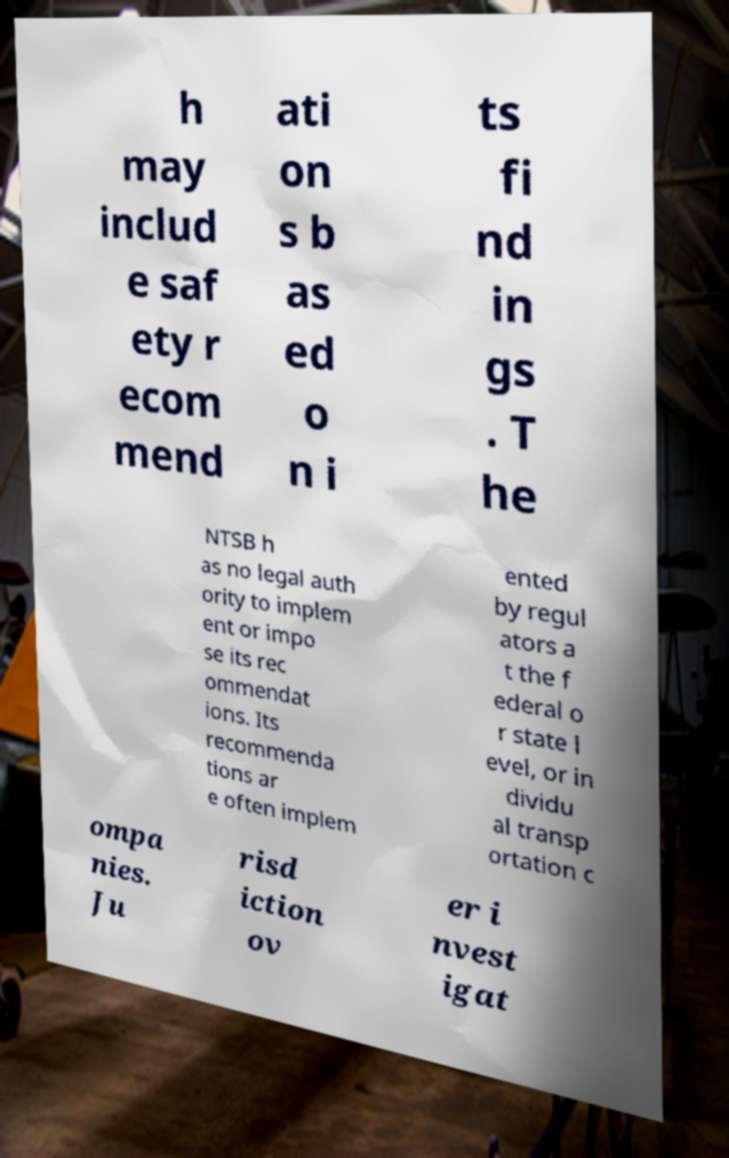Can you accurately transcribe the text from the provided image for me? h may includ e saf ety r ecom mend ati on s b as ed o n i ts fi nd in gs . T he NTSB h as no legal auth ority to implem ent or impo se its rec ommendat ions. Its recommenda tions ar e often implem ented by regul ators a t the f ederal o r state l evel, or in dividu al transp ortation c ompa nies. Ju risd iction ov er i nvest igat 